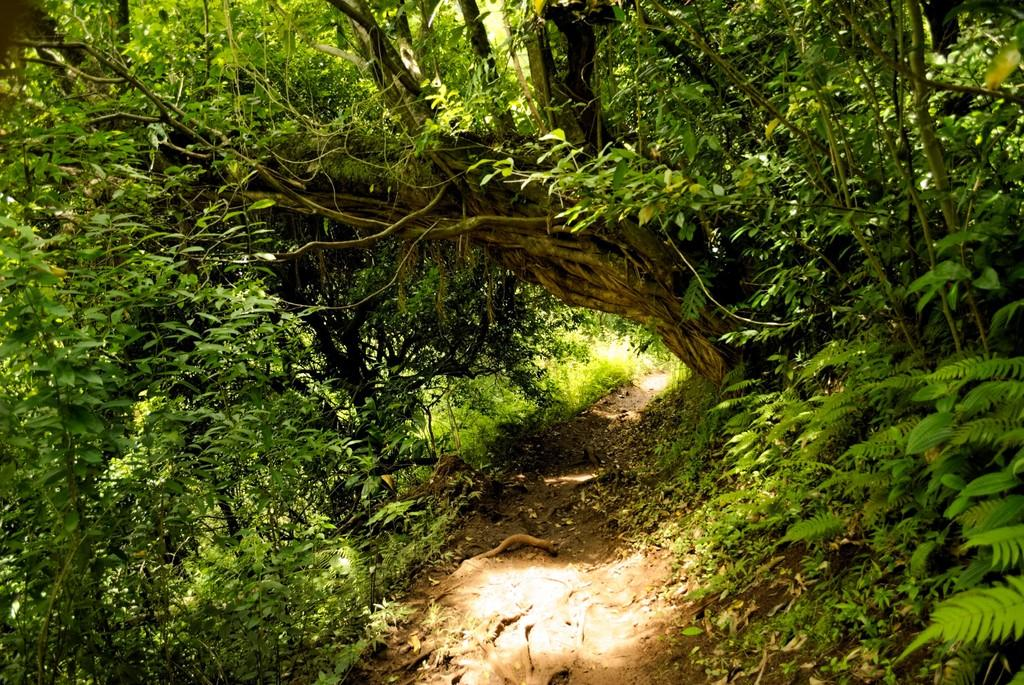What can be seen running through the area in the image? There is a path in the image. What is located alongside the path? Plants and trees are present on both sides of the path. Can you describe the big tree visible in the background of the image? The big tree is on a hill in the background of the image. What type of writing can be seen on the pan in the image? There is no pan or writing present in the image. Is there a guitar visible in the image? There is no guitar present in the image. 